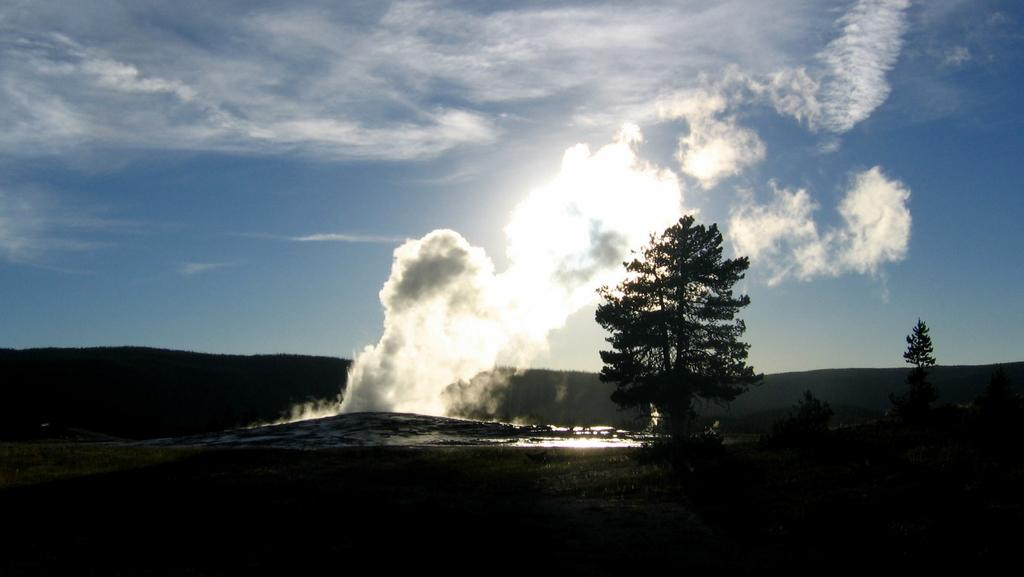What geographical feature is the main subject of the image? There is a small mountain in the image. What is happening to the mountain? Smoke is coming out of the mountain. Are there any other plants or vegetation in the image? There is a tree beside the mountain. What can be seen in the distance behind the mountain? There are other mountains visible in the background. What color is the sweater worn by the chalk in the image? There is no sweater or chalk present in the image; it features a small mountain with smoke coming out of it and a tree beside it. 